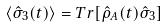<formula> <loc_0><loc_0><loc_500><loc_500>\langle \hat { \sigma } _ { 3 } ( t ) \rangle = T r [ \hat { \rho } _ { A } ( t ) \hat { \sigma } _ { 3 } ]</formula> 